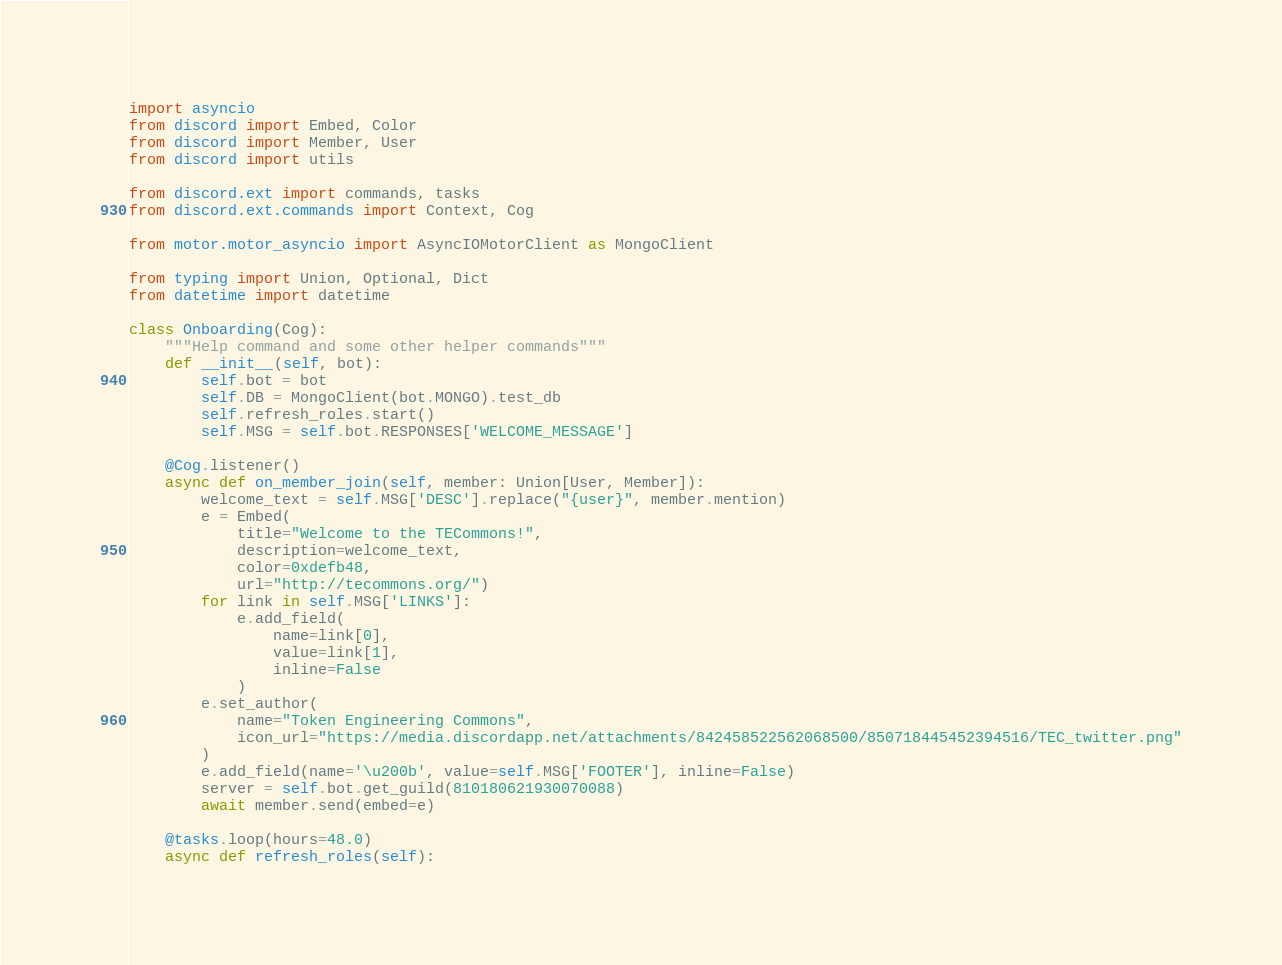<code> <loc_0><loc_0><loc_500><loc_500><_Python_>import asyncio
from discord import Embed, Color
from discord import Member, User
from discord import utils

from discord.ext import commands, tasks
from discord.ext.commands import Context, Cog

from motor.motor_asyncio import AsyncIOMotorClient as MongoClient

from typing import Union, Optional, Dict
from datetime import datetime

class Onboarding(Cog):
    """Help command and some other helper commands"""
    def __init__(self, bot):
        self.bot = bot
        self.DB = MongoClient(bot.MONGO).test_db
        self.refresh_roles.start()
        self.MSG = self.bot.RESPONSES['WELCOME_MESSAGE']

    @Cog.listener()
    async def on_member_join(self, member: Union[User, Member]):
        welcome_text = self.MSG['DESC'].replace("{user}", member.mention)
        e = Embed(
            title="Welcome to the TECommons!",
            description=welcome_text,
            color=0xdefb48,
            url="http://tecommons.org/")
        for link in self.MSG['LINKS']:
            e.add_field(
                name=link[0],
                value=link[1],
                inline=False
            )
        e.set_author(
            name="Token Engineering Commons",
            icon_url="https://media.discordapp.net/attachments/842458522562068500/850718445452394516/TEC_twitter.png"
        )
        e.add_field(name='\u200b', value=self.MSG['FOOTER'], inline=False)
        server = self.bot.get_guild(810180621930070088)
        await member.send(embed=e)

    @tasks.loop(hours=48.0)
    async def refresh_roles(self):</code> 